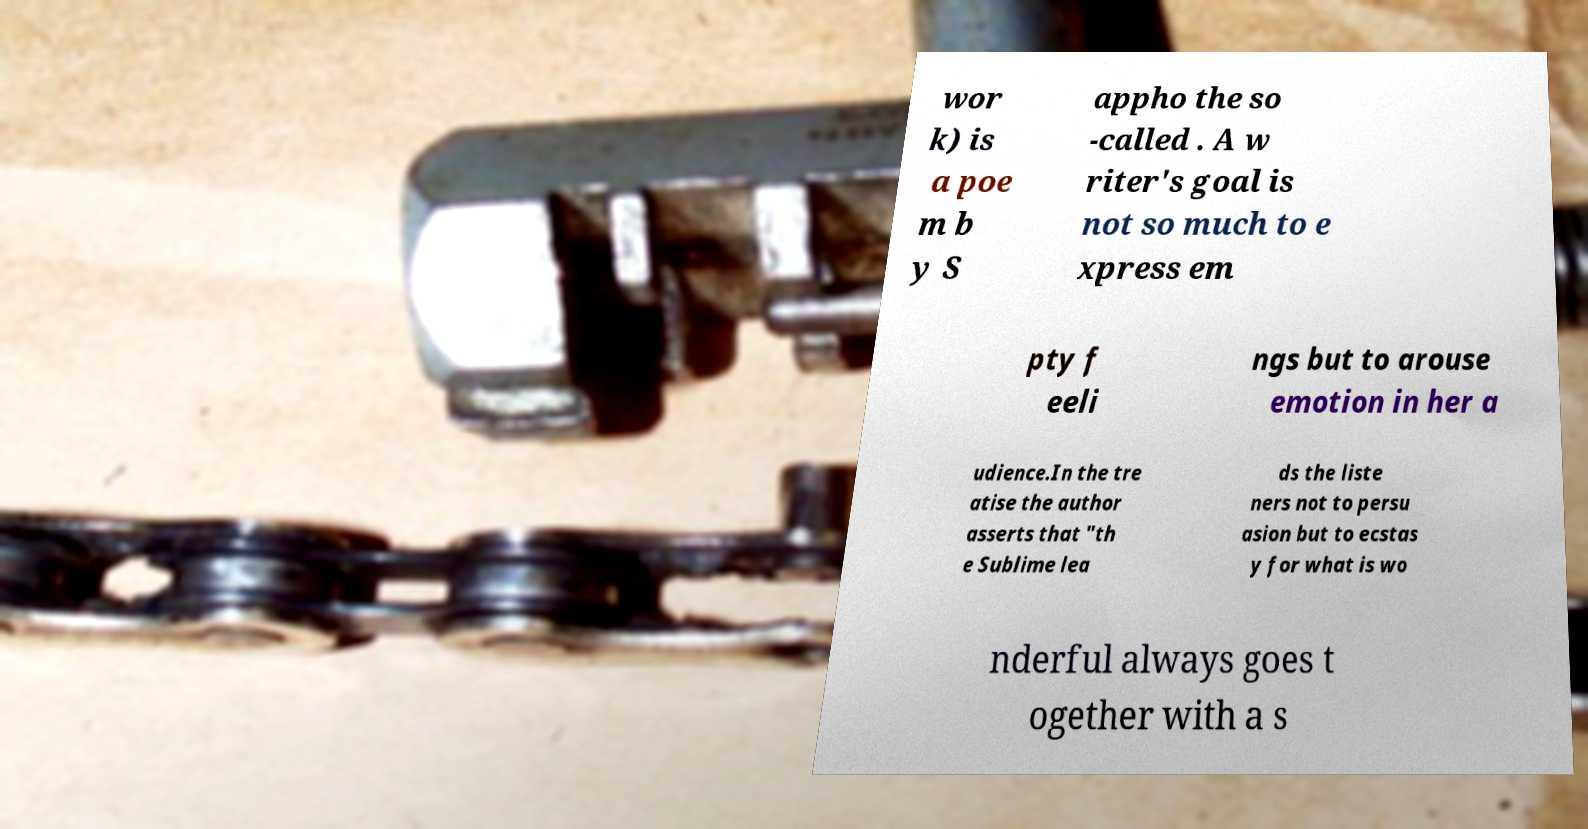There's text embedded in this image that I need extracted. Can you transcribe it verbatim? wor k) is a poe m b y S appho the so -called . A w riter's goal is not so much to e xpress em pty f eeli ngs but to arouse emotion in her a udience.In the tre atise the author asserts that "th e Sublime lea ds the liste ners not to persu asion but to ecstas y for what is wo nderful always goes t ogether with a s 